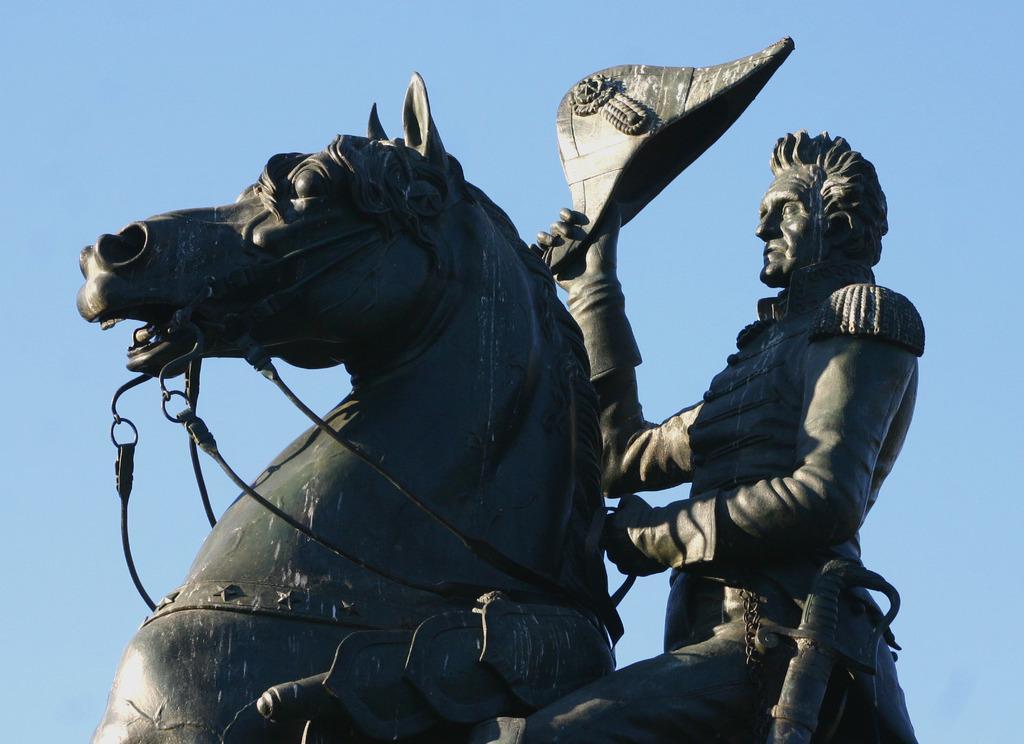Please provide a concise description of this image. Here we can see a statue of a horse and a person holding hat 